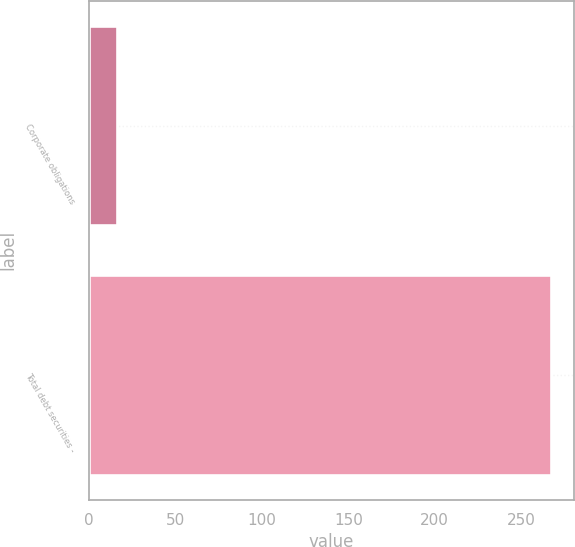Convert chart to OTSL. <chart><loc_0><loc_0><loc_500><loc_500><bar_chart><fcel>Corporate obligations<fcel>Total debt securities -<nl><fcel>16<fcel>267<nl></chart> 